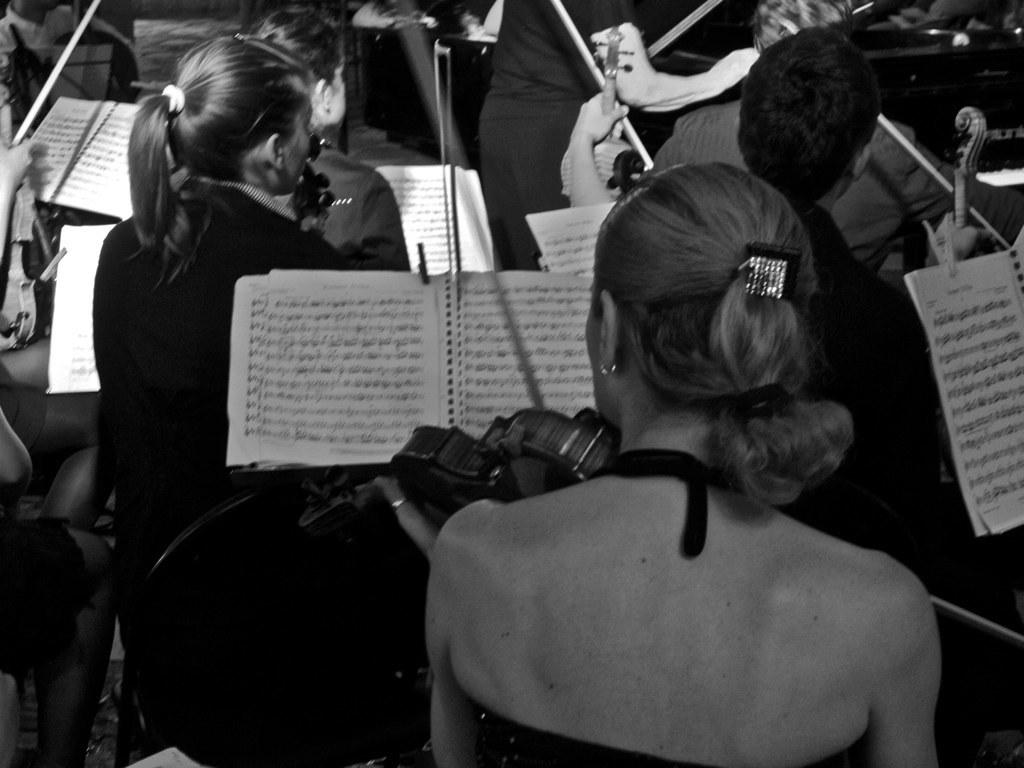What is happening in the image involving the group of people? The people in the image are playing violins. What objects are visible in front of the people? There are books visible in front of the people. What type of clouds can be seen in the image? There are no clouds visible in the image; it features a group of people playing violins with books in front of them. 